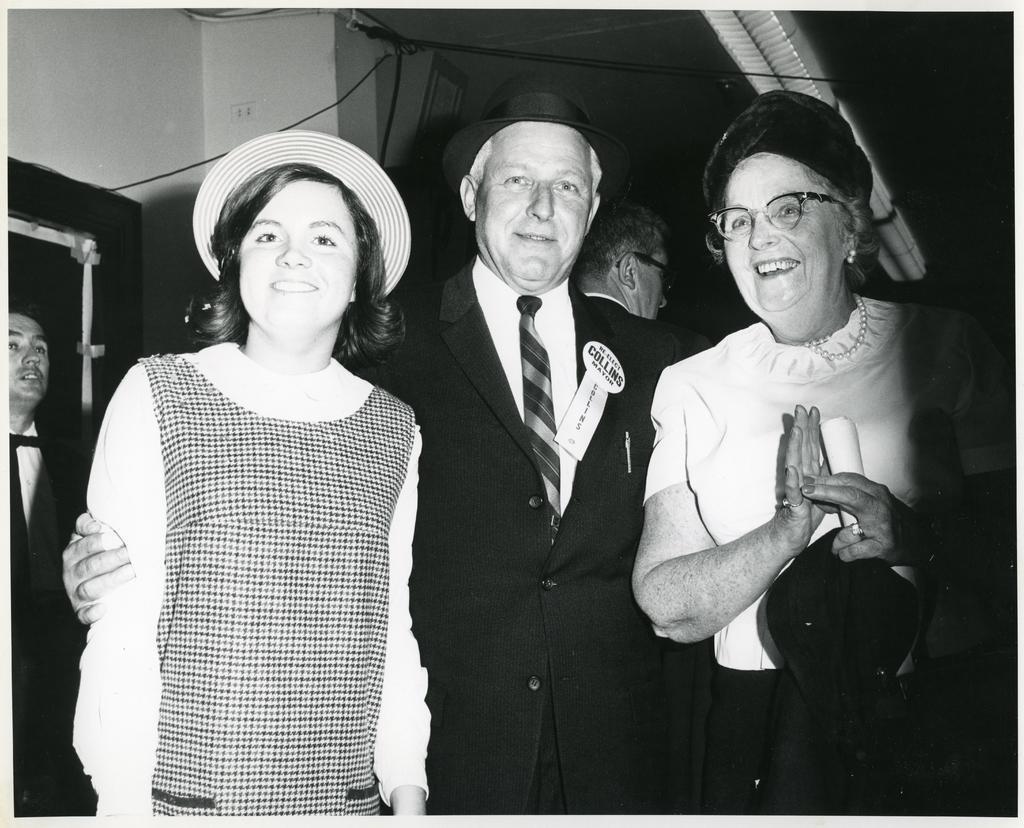Could you give a brief overview of what you see in this image? In this picture I can see there are three people standing here and among them there are two women and they are smiling and the man is standing in between them. In the backdrop there is a wall. 